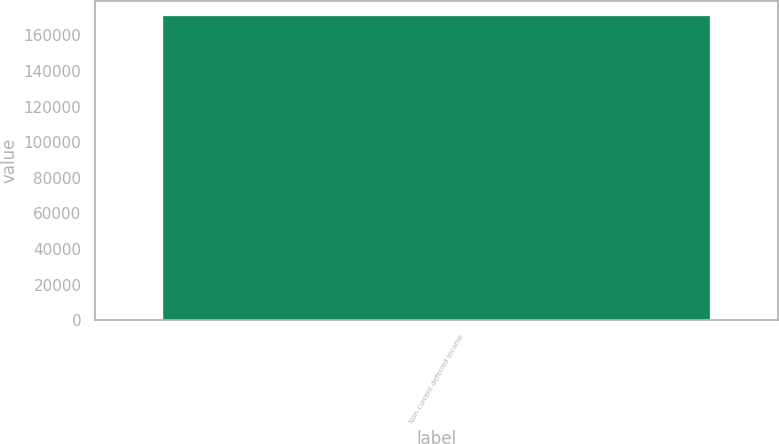Convert chart to OTSL. <chart><loc_0><loc_0><loc_500><loc_500><bar_chart><fcel>Non-current deferred income<nl><fcel>170723<nl></chart> 